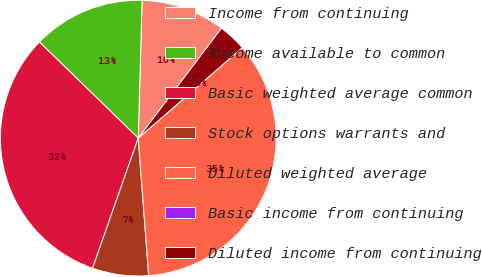Convert chart to OTSL. <chart><loc_0><loc_0><loc_500><loc_500><pie_chart><fcel>Income from continuing<fcel>Income available to common<fcel>Basic weighted average common<fcel>Stock options warrants and<fcel>Diluted weighted average<fcel>Basic income from continuing<fcel>Diluted income from continuing<nl><fcel>9.87%<fcel>13.16%<fcel>31.9%<fcel>6.58%<fcel>35.19%<fcel>0.0%<fcel>3.29%<nl></chart> 